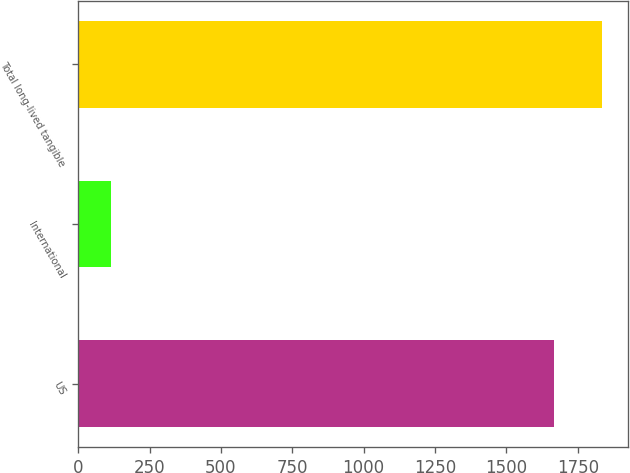<chart> <loc_0><loc_0><loc_500><loc_500><bar_chart><fcel>US<fcel>International<fcel>Total long-lived tangible<nl><fcel>1668<fcel>116<fcel>1834.8<nl></chart> 